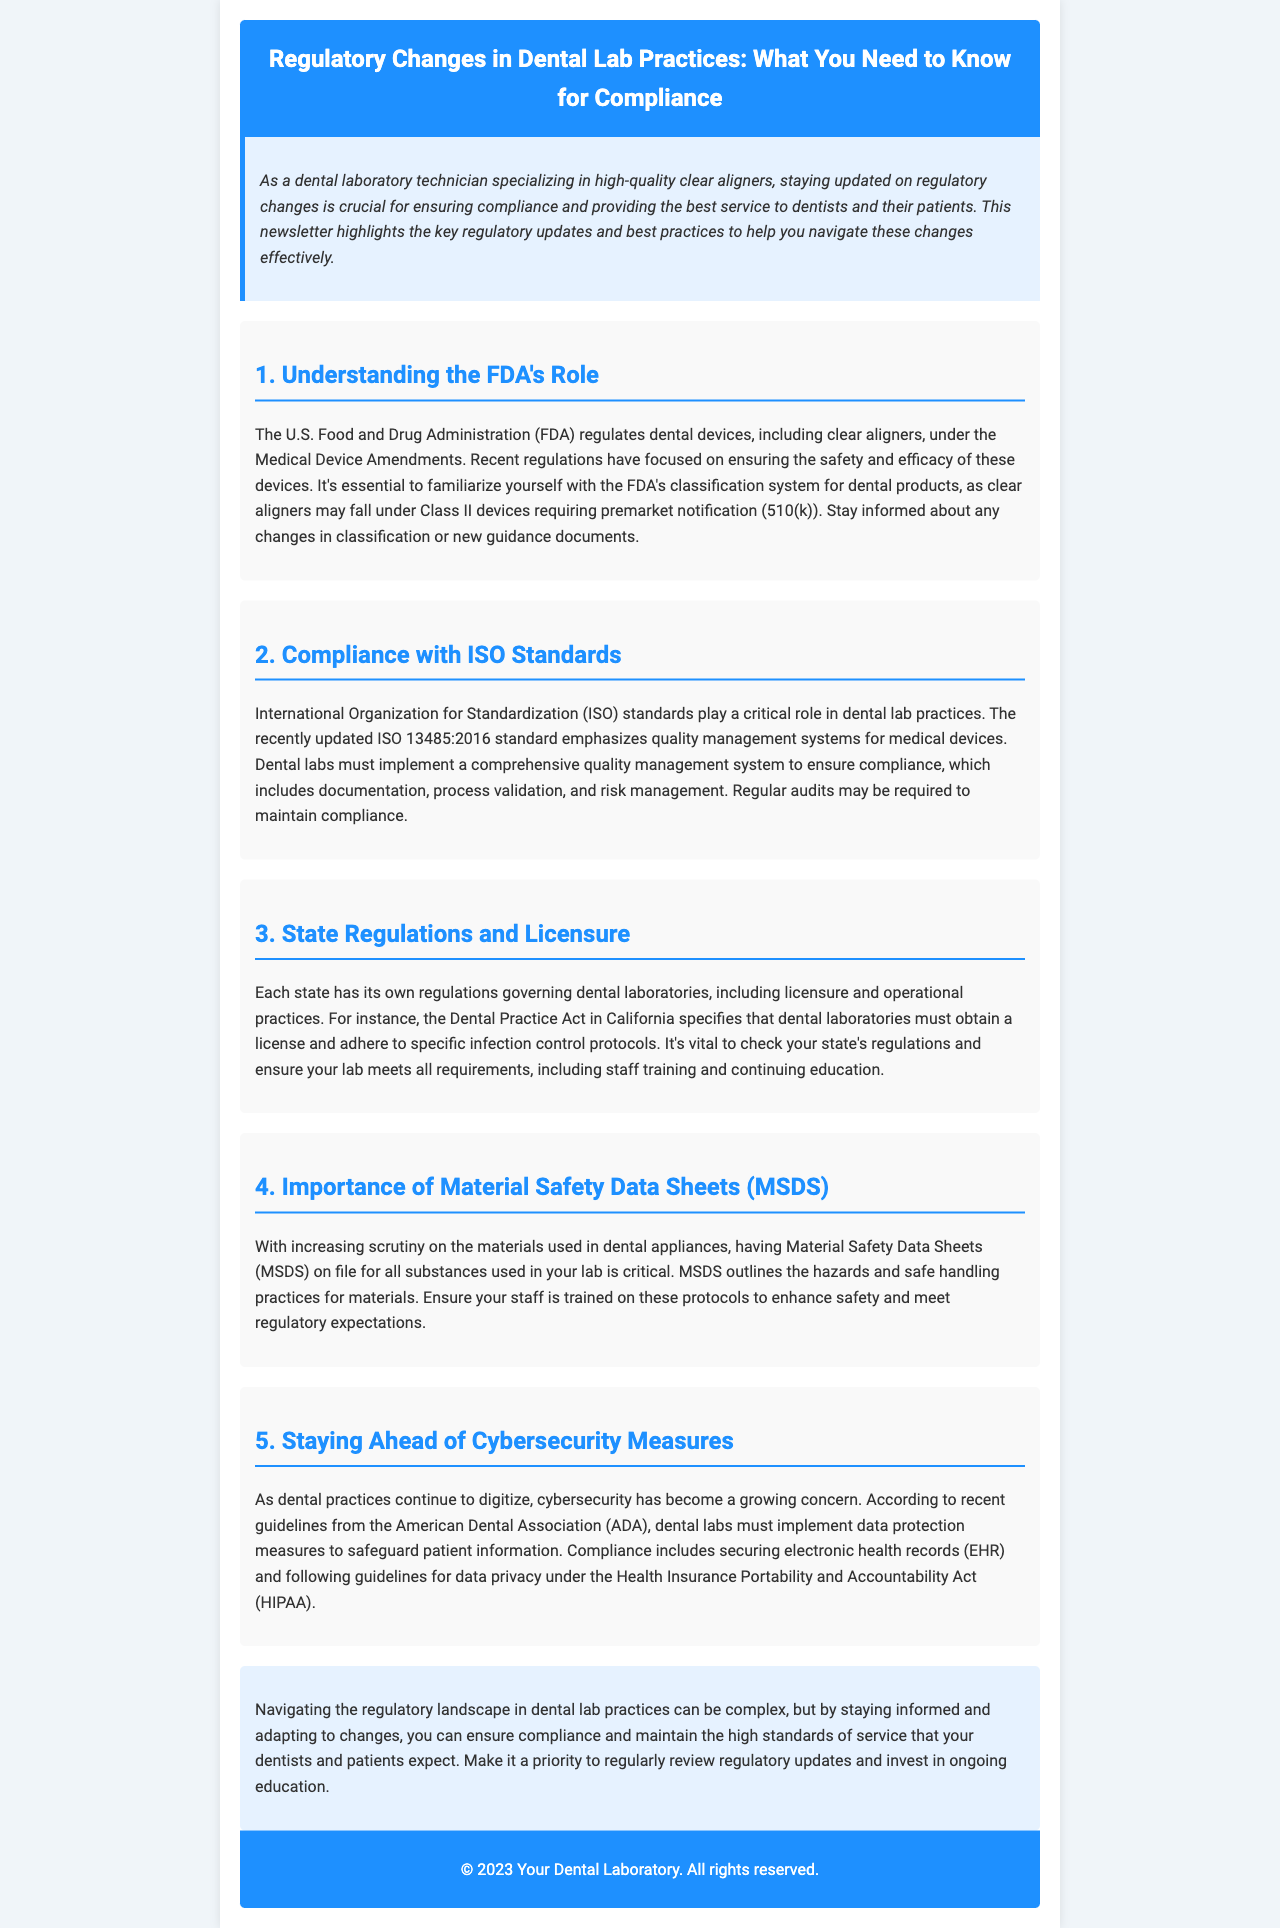What is the FDA's role in dental lab practices? The FDA regulates dental devices, including clear aligners, under the Medical Device Amendments, focusing on safety and efficacy.
Answer: Regulates dental devices What does ISO 13485:2016 emphasize? ISO 13485:2016 emphasizes quality management systems for medical devices.
Answer: Quality management systems What must California dental laboratories obtain? The Dental Practice Act in California specifies that dental laboratories must obtain a license.
Answer: A license What is critical to have on file for lab materials? Material Safety Data Sheets (MSDS) outline the hazards and safe handling practices for materials used in dental appliances.
Answer: MSDS What organization provides guidelines for data protection? The American Dental Association (ADA) provides guidelines for data protection measures in dental labs.
Answer: American Dental Association Why is it important to stay informed about regulations? Staying informed and adapting to changes helps ensure compliance and maintain high standards of service.
Answer: Ensure compliance What is one requirement for maintaining compliance with ISO standards? Regular audits may be required to maintain compliance with ISO standards.
Answer: Regular audits Which act governs infection control protocols in laboratories? The Dental Practice Act specifies infection control protocols for dental laboratories.
Answer: Dental Practice Act 